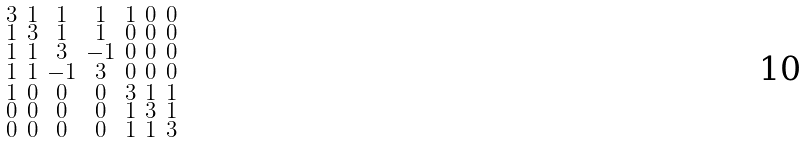<formula> <loc_0><loc_0><loc_500><loc_500>\begin{smallmatrix} 3 & 1 & 1 & 1 & 1 & 0 & 0 \\ 1 & 3 & 1 & 1 & 0 & 0 & 0 \\ 1 & 1 & 3 & - 1 & 0 & 0 & 0 \\ 1 & 1 & - 1 & 3 & 0 & 0 & 0 \\ 1 & 0 & 0 & 0 & 3 & 1 & 1 \\ 0 & 0 & 0 & 0 & 1 & 3 & 1 \\ 0 & 0 & 0 & 0 & 1 & 1 & 3 \end{smallmatrix}</formula> 